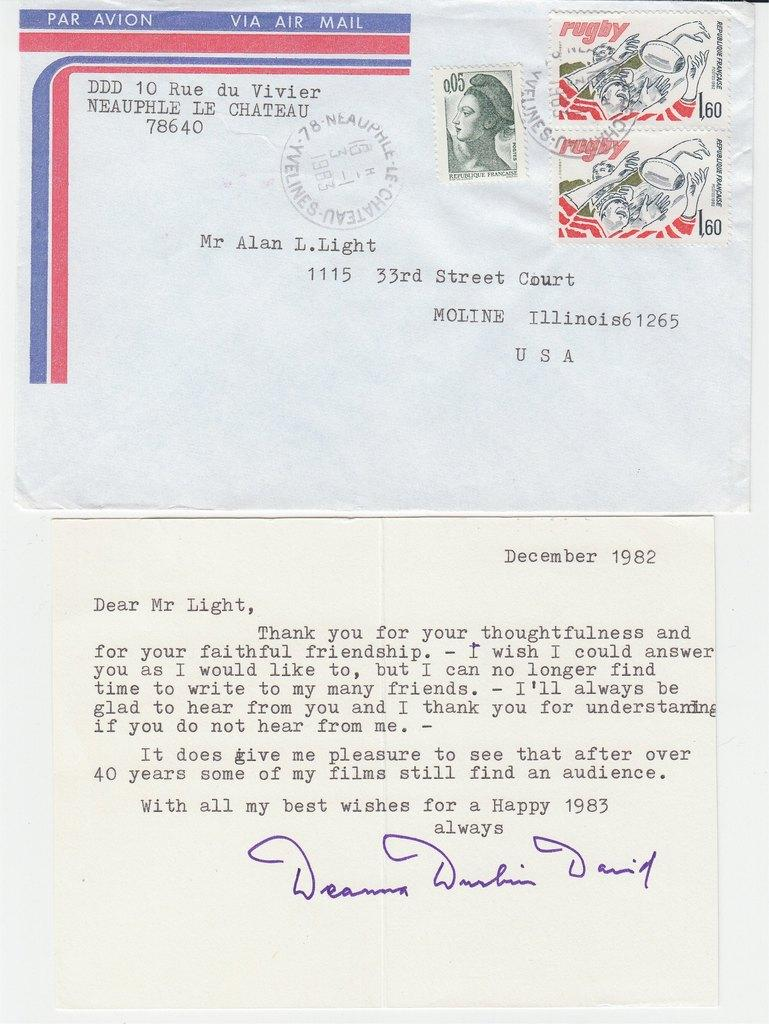What is present on the paper in the image? There is printed text on the paper. Are there any additional elements on the paper besides the text? Yes, there are stamps on the paper. What type of lettuce can be seen in the image? There is no lettuce present in the image; it features a paper with printed text and stamps. What kind of humor is depicted in the image? There is no humor depicted in the image; it is a straightforward representation of a paper with printed text and stamps. 